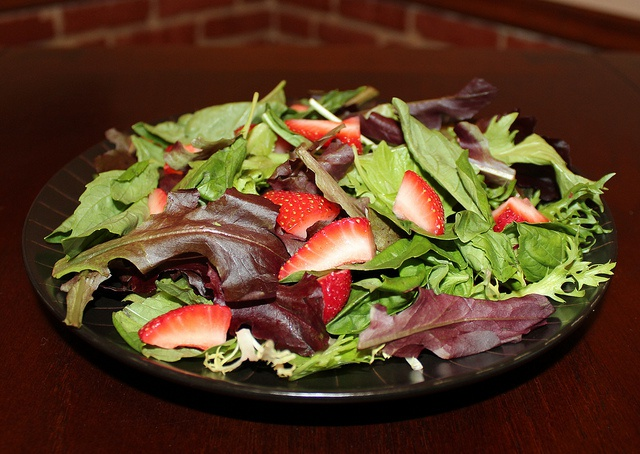Describe the objects in this image and their specific colors. I can see a dining table in black, maroon, and olive tones in this image. 